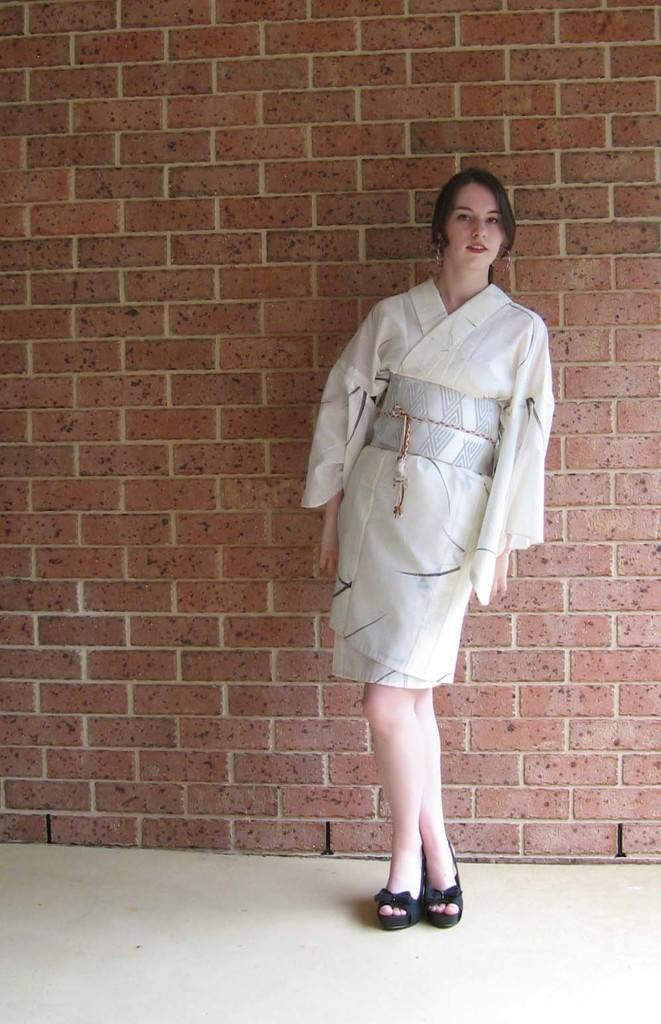Who is the main subject in the image? There is a girl in the image. Where is the girl positioned in the image? The girl is standing on the right side of the image. What can be seen in the background of the image? There is a wall in the background of the image. What language is the girl speaking in the image? There is no indication of the girl speaking in the image, nor is there any information about the language she might be speaking. 